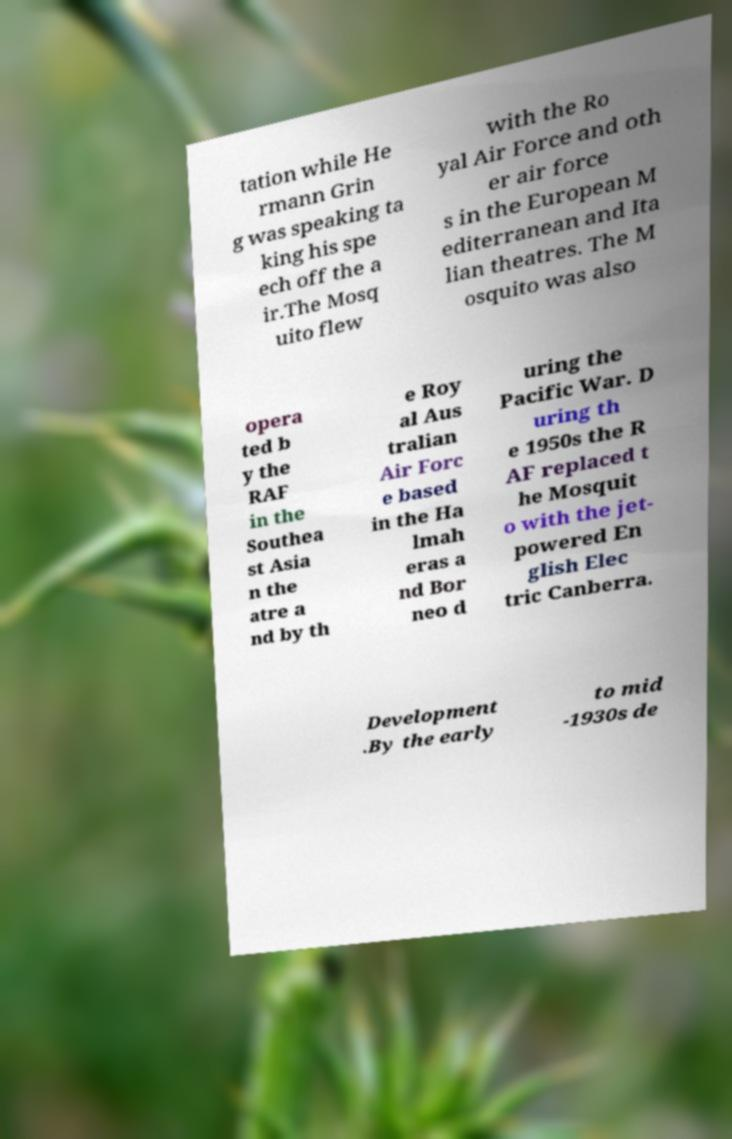Can you read and provide the text displayed in the image?This photo seems to have some interesting text. Can you extract and type it out for me? tation while He rmann Grin g was speaking ta king his spe ech off the a ir.The Mosq uito flew with the Ro yal Air Force and oth er air force s in the European M editerranean and Ita lian theatres. The M osquito was also opera ted b y the RAF in the Southea st Asia n the atre a nd by th e Roy al Aus tralian Air Forc e based in the Ha lmah eras a nd Bor neo d uring the Pacific War. D uring th e 1950s the R AF replaced t he Mosquit o with the jet- powered En glish Elec tric Canberra. Development .By the early to mid -1930s de 